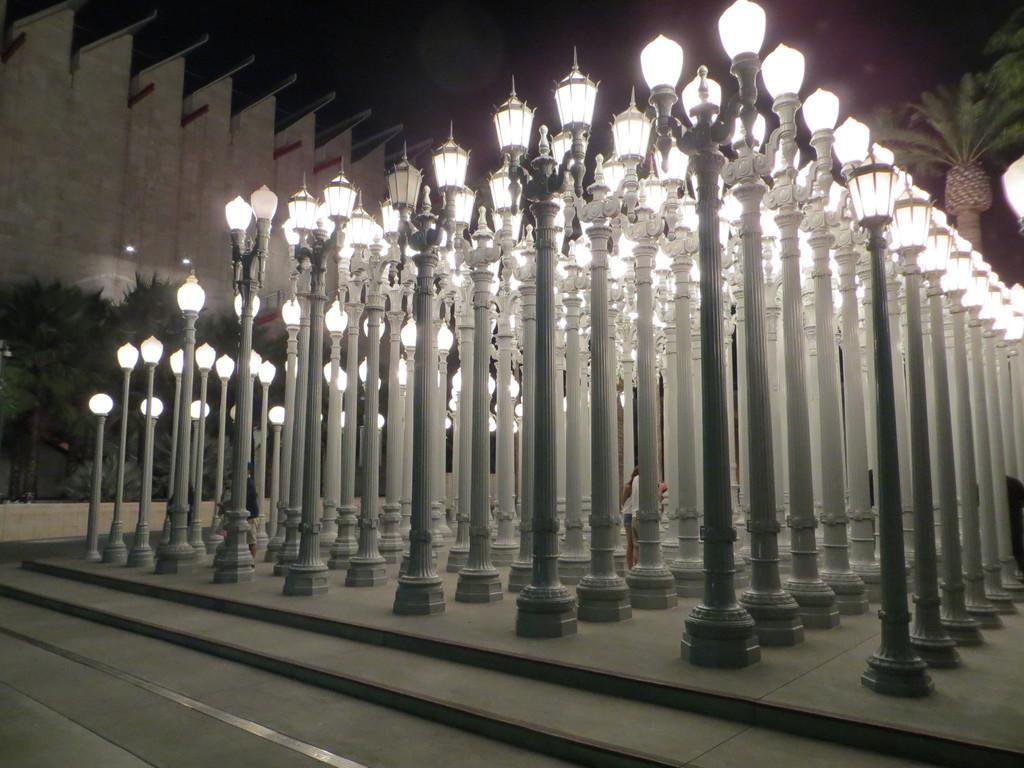Please provide a concise description of this image. In this image we can see many plants and a tree. There are many street lamps in the image. There are staircases in the image. There is a wall at the left side of the image. There is a sky in the image. 